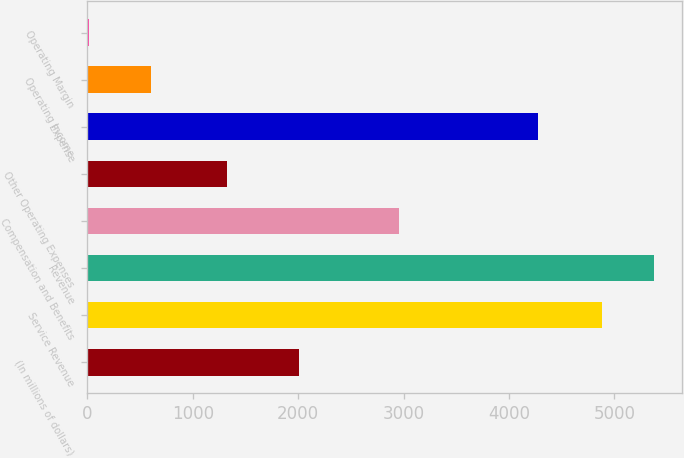Convert chart to OTSL. <chart><loc_0><loc_0><loc_500><loc_500><bar_chart><fcel>(In millions of dollars)<fcel>Service Revenue<fcel>Revenue<fcel>Compensation and Benefits<fcel>Other Operating Expenses<fcel>Expense<fcel>Operating Income<fcel>Operating Margin<nl><fcel>2007<fcel>4884<fcel>5371.16<fcel>2951<fcel>1327<fcel>4278<fcel>606<fcel>12.4<nl></chart> 